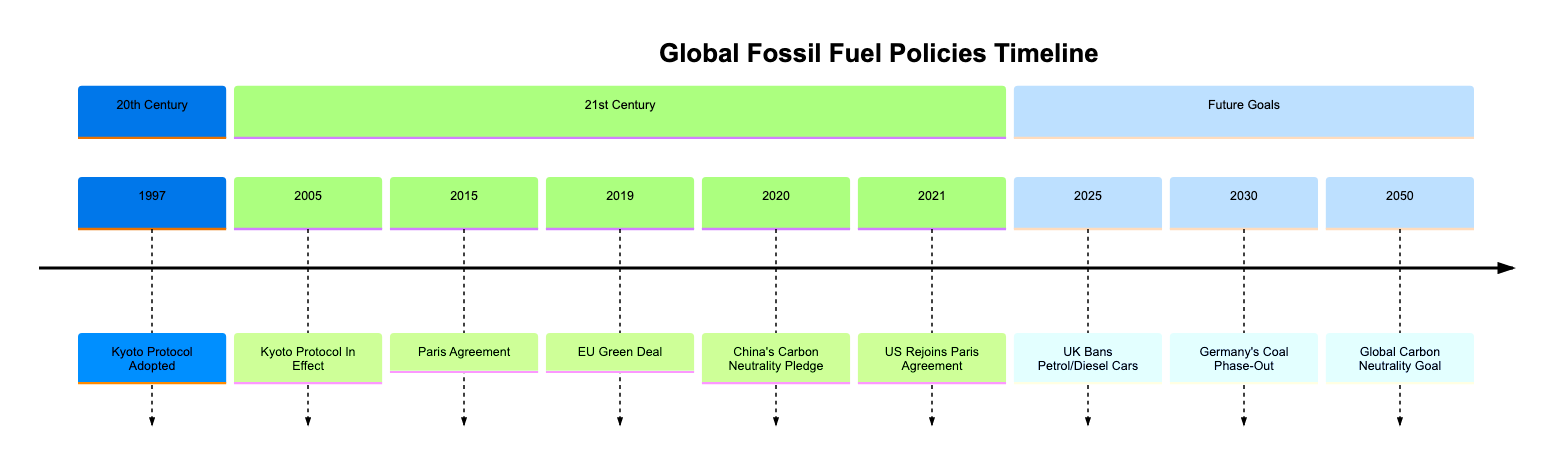What year was the Kyoto Protocol adopted? The diagram shows that the Kyoto Protocol was adopted in 1997, which is explicitly stated next to the event in the timeline.
Answer: 1997 How many major policies are listed in the timeline? By counting the events in the timeline, we see that there are a total of 9 major policies and regulations included, from the Kyoto Protocol in 1997 to the Global Carbon Neutrality Goal in 2050.
Answer: 9 What is the main goal of the Paris Agreement? The timeline describes the Paris Agreement, adopted in 2015, with the goal to limit global warming to below 2 degrees Celsius compared to pre-industrial levels.
Answer: Limit global warming Which country made a carbon neutrality pledge in 2020? According to the timeline, China's Carbon Neutrality Pledge in 2020 indicates that China aims to reach peak emissions by 2030 and achieve carbon neutrality by 2060.
Answer: China What specific target is set by the UK by 2025? The timeline specifies that by 2025, the UK plans to ban the sale of new petrol and diesel cars, aiming to accelerate the shift towards electric vehicles.
Answer: Ban on petrol and diesel cars How many years after the Kyoto Protocol came into effect was the Paris Agreement adopted? The Kyoto Protocol came into effect in 2005 and the Paris Agreement was adopted in 2015, which is a span of 10 years between these two events.
Answer: 10 years What year does Germany plan to phase out coal-fired power plants? The timeline indicates that Germany is targeting 2030 for significant progress towards shutting down all remaining coal-fired power plants by 2038.
Answer: 2030 Which countries are targeting carbon neutrality by 2050? The timeline notes that several countries, including the EU, Japan, and South Korea, are setting their target for achieving carbon neutrality in the year 2050.
Answer: EU, Japan, South Korea What was the implication of the US rejoining the Paris Agreement? The timeline explains that the United States reaffirmed its commitments to reduce fossil fuel emissions after rejoining the Paris Agreement in 2021.
Answer: Reaffirmed commitments to reduce emissions 